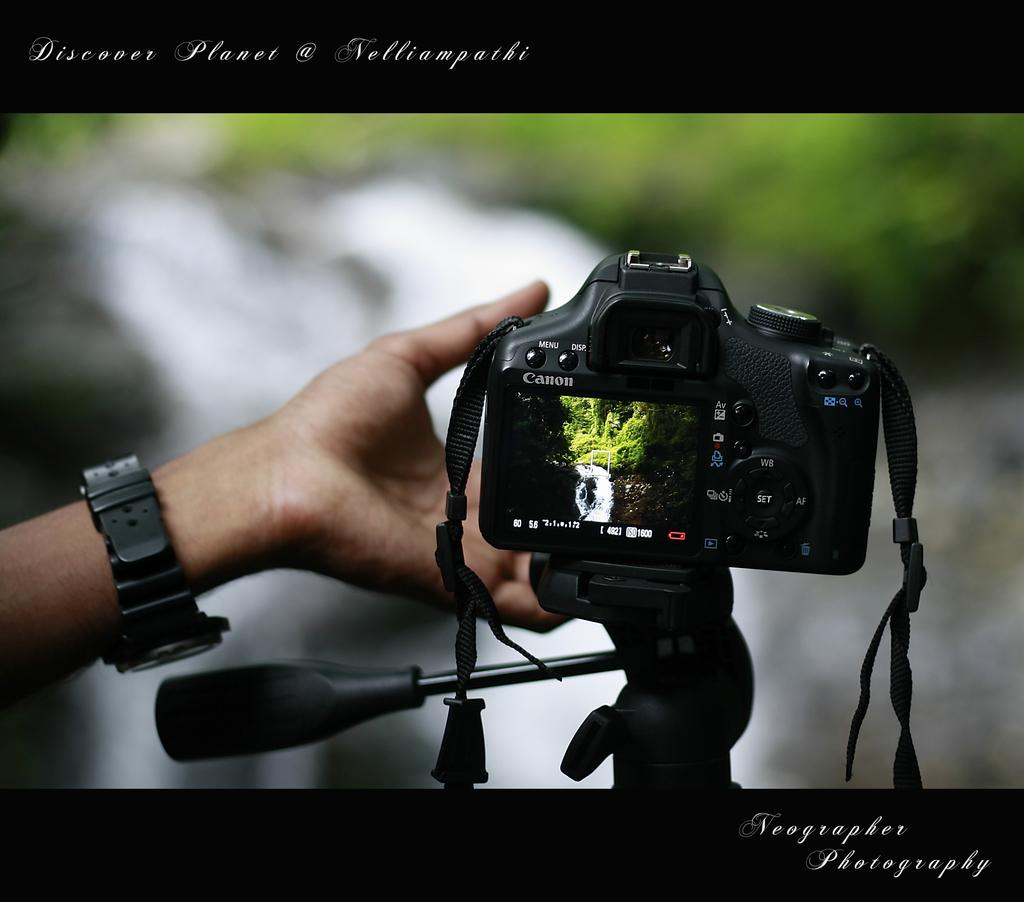<image>
Create a compact narrative representing the image presented. the word planet is above the canon camera 